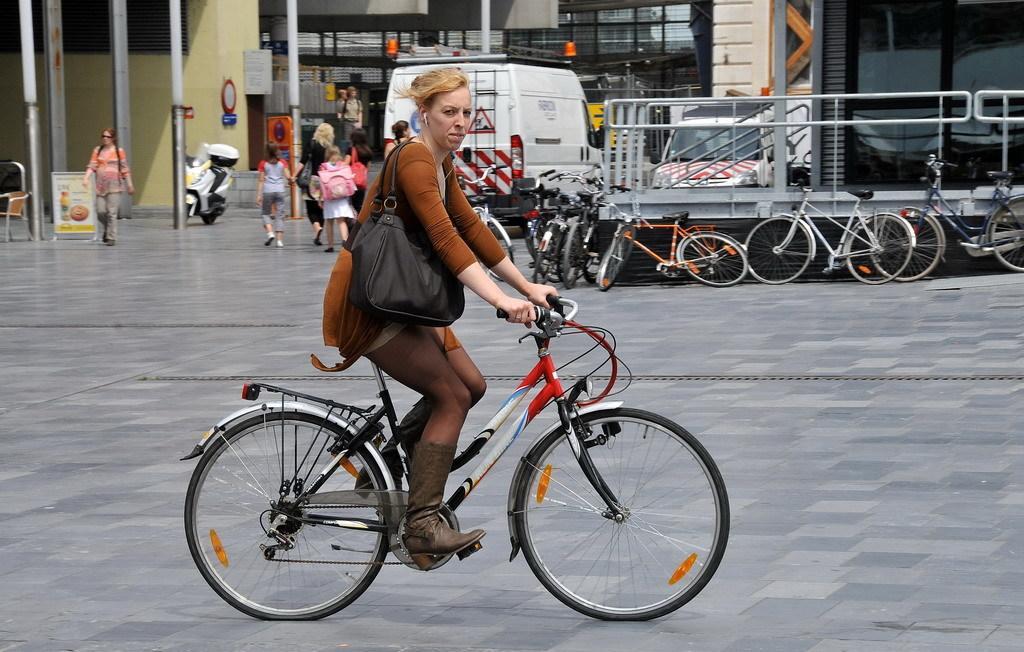Could you give a brief overview of what you see in this image? In the middle bottom, a woman is riding a bicycle and she is wearing a black color bag. In the left middle, there are group of people walking on the road and bikes are parked and in the middle there are bicycles parked on the road. In the top there is a building visible. This image is taken on the road during day time. 